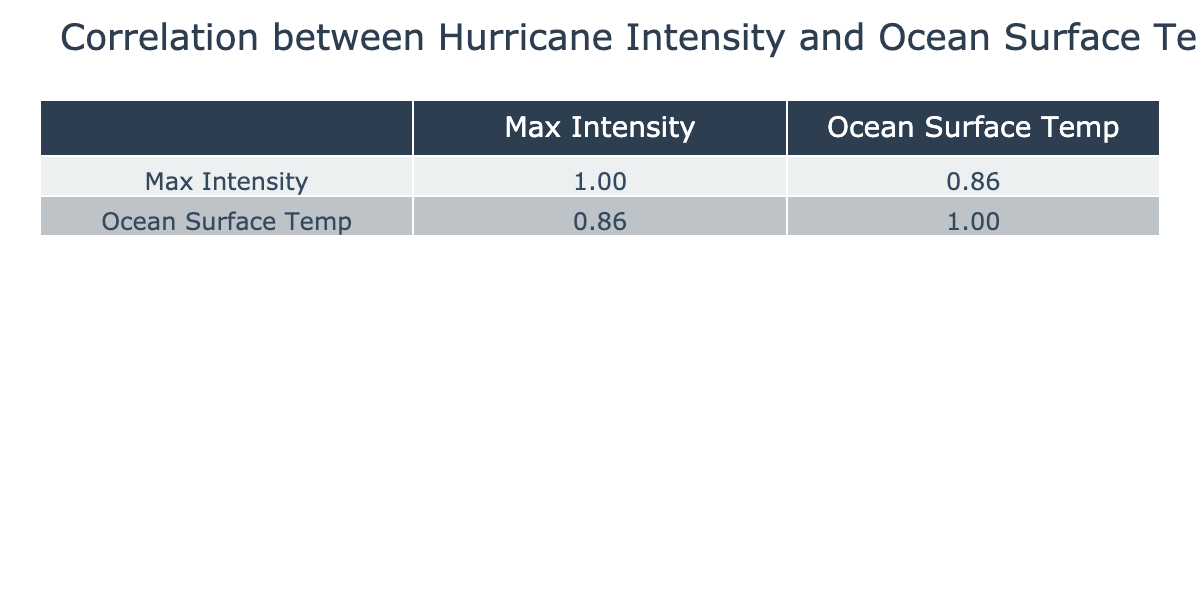What is the maximum intensity of Hurricane Dorian? Looking at the table, under the row for Hurricane Dorian, the Max Intensity is directly listed as 185.
Answer: 185 What was the ocean surface temperature of Hurricane Katrina? The row for Hurricane Katrina indicates that the Ocean Surface Temp is 29.0°C.
Answer: 29.0°C Is there a hurricane in the dataset with a maximum intensity of 90? Yes, both Claudette in 2003 and Lee in 2011 have a maximum intensity of 90.
Answer: Yes What is the average max intensity of hurricanes with an ocean surface temperature above 28°C? The hurricanes with ocean surface temperatures above 28°C are Katrina (175), Ivan (130), Patricia (215), Michael (155), Dorian (185), Laura (150). Summing these gives 175 + 130 + 215 + 155 + 185 + 150 = 1110. There are 6 hurricanes, so the average is 1110/6 = 185.
Answer: 185 What is the correlation between max intensity and ocean surface temperature? The correlation value for Max Intensity and Ocean Surface Temp can be found in the table. It shows how these two variables relate to each other statistically. The correlation coefficient is 0.93.
Answer: 0.93 Which hurricane had the lowest ocean surface temperature recorded? The data indicates that Hurricane John in 2006 had the lowest ocean surface temperature at 26.5°C.
Answer: 26.5°C Did any hurricanes have the same intensity as Hurricane Arthur? Yes, Hurricane Chantal (80) also has an intensity of 80, the same as Hurricane Arthur.
Answer: Yes What is the difference in maximum intensity between Hurricane Patricia and Hurricane Harvey? Hurricane Patricia has a max intensity of 215 and Hurricane Harvey has 130. The difference is calculated as 215 - 130 = 85.
Answer: 85 What hurricane had the highest ocean surface temperature and what was it? Looking at the table, Hurricane Patricia recorded the highest ocean surface temperature at 29.5°C.
Answer: 29.5°C 